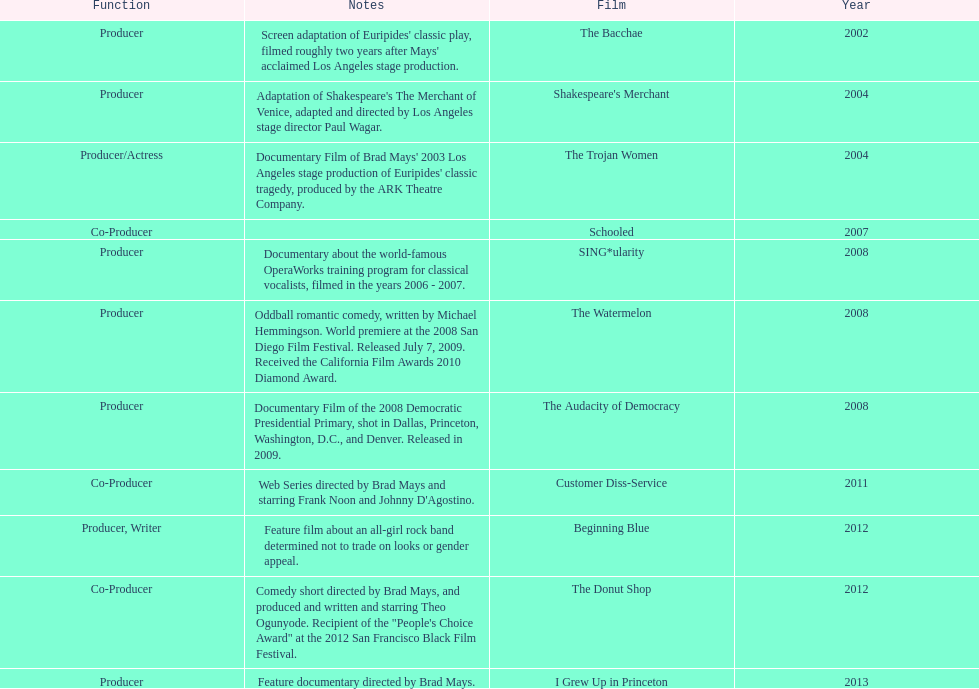Which film was before the audacity of democracy? The Watermelon. 